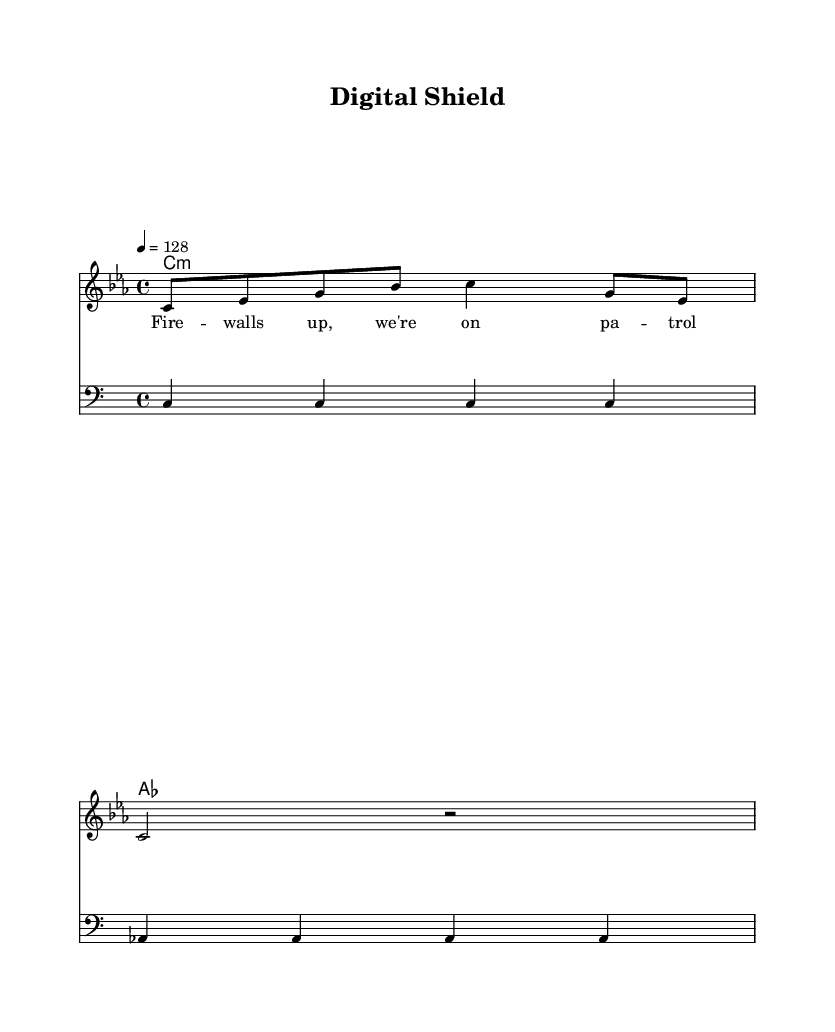What is the key signature of this music? The key signature can be identified at the beginning of the sheet music, where it is indicated by the key signature symbol. In this case, it shows three flats, indicating C minor.
Answer: C minor What is the time signature of this piece? The time signature appears at the start of the music, represented as “4/4,” meaning there are four beats in a measure and the quarter note gets one beat.
Answer: 4/4 What is the tempo marking of this composition? The tempo marking can be found at the top of the sheet music, noted as "4 = 128," which indicates that there are 128 beats per minute.
Answer: 128 How many measures are in the melody? The melody section shows two distinct measures. Counting the vertical lines in the melody staff confirms this.
Answer: 2 What chords are used in the harmony? The harmony section shows the chord symbols placed above the staff. It includes “C minor” and “A flat major.”
Answer: C minor, A flat major What genre does this piece belong to? The title and thematic content suggest this piece falls into the electronic dance music genre, characterized by its upbeat tempo and danceable rhythm.
Answer: Electronic dance music What is the primary lyrical theme of this piece? The lyrics depict a cyber-themed narrative about protection and surveillance, as suggested by the phrase “Fire walls up, we’re on patrol.”
Answer: Cybersecurity 